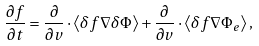Convert formula to latex. <formula><loc_0><loc_0><loc_500><loc_500>\frac { \partial f } { \partial t } = \frac { \partial } { \partial { v } } \cdot \left \langle \delta f \nabla \delta \Phi \right \rangle + \frac { \partial } { \partial { v } } \cdot \left \langle \delta f \nabla \Phi _ { e } \right \rangle ,</formula> 